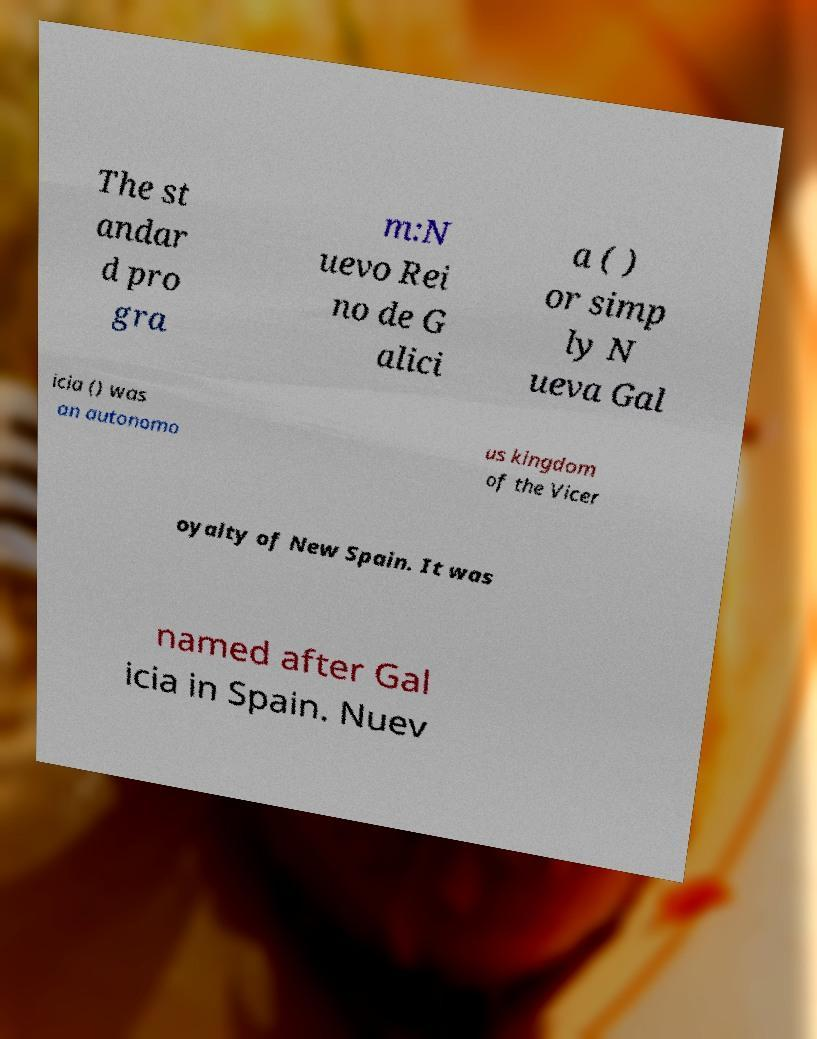Could you assist in decoding the text presented in this image and type it out clearly? The st andar d pro gra m:N uevo Rei no de G alici a ( ) or simp ly N ueva Gal icia () was an autonomo us kingdom of the Vicer oyalty of New Spain. It was named after Gal icia in Spain. Nuev 